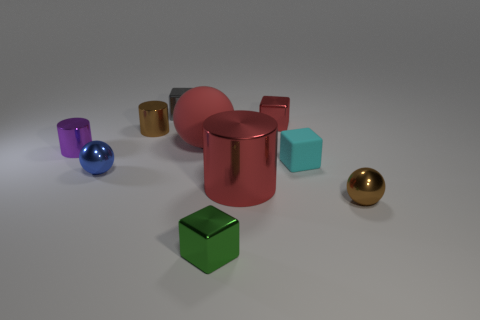Is there anything else that is the same color as the large cylinder?
Offer a very short reply. Yes. Is the color of the tiny matte block the same as the big matte thing?
Give a very brief answer. No. What shape is the large shiny object that is the same color as the big ball?
Your response must be concise. Cylinder. Is there a tiny purple sphere that has the same material as the cyan block?
Your answer should be very brief. No. Are the brown cylinder and the cube in front of the brown metal sphere made of the same material?
Your response must be concise. Yes. The rubber cube that is the same size as the brown metal sphere is what color?
Your response must be concise. Cyan. What is the size of the brown shiny thing that is behind the tiny brown shiny object that is to the right of the small gray block?
Provide a short and direct response. Small. Is the color of the large sphere the same as the small metallic block that is to the left of the big red rubber sphere?
Your answer should be compact. No. Are there fewer rubber things in front of the tiny green shiny object than small shiny objects?
Provide a short and direct response. Yes. What number of other objects are there of the same size as the red shiny cube?
Your answer should be compact. 7. 